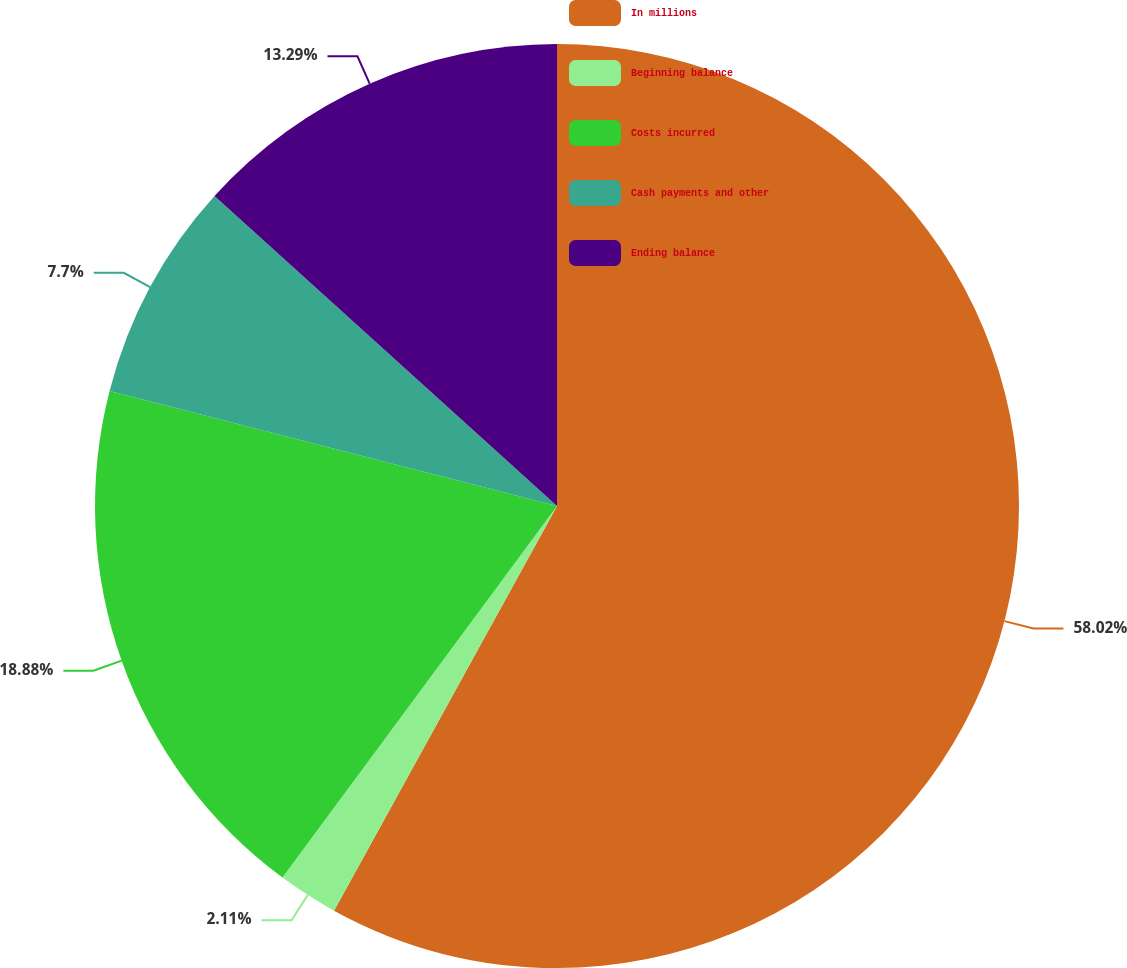Convert chart to OTSL. <chart><loc_0><loc_0><loc_500><loc_500><pie_chart><fcel>In millions<fcel>Beginning balance<fcel>Costs incurred<fcel>Cash payments and other<fcel>Ending balance<nl><fcel>58.01%<fcel>2.11%<fcel>18.88%<fcel>7.7%<fcel>13.29%<nl></chart> 